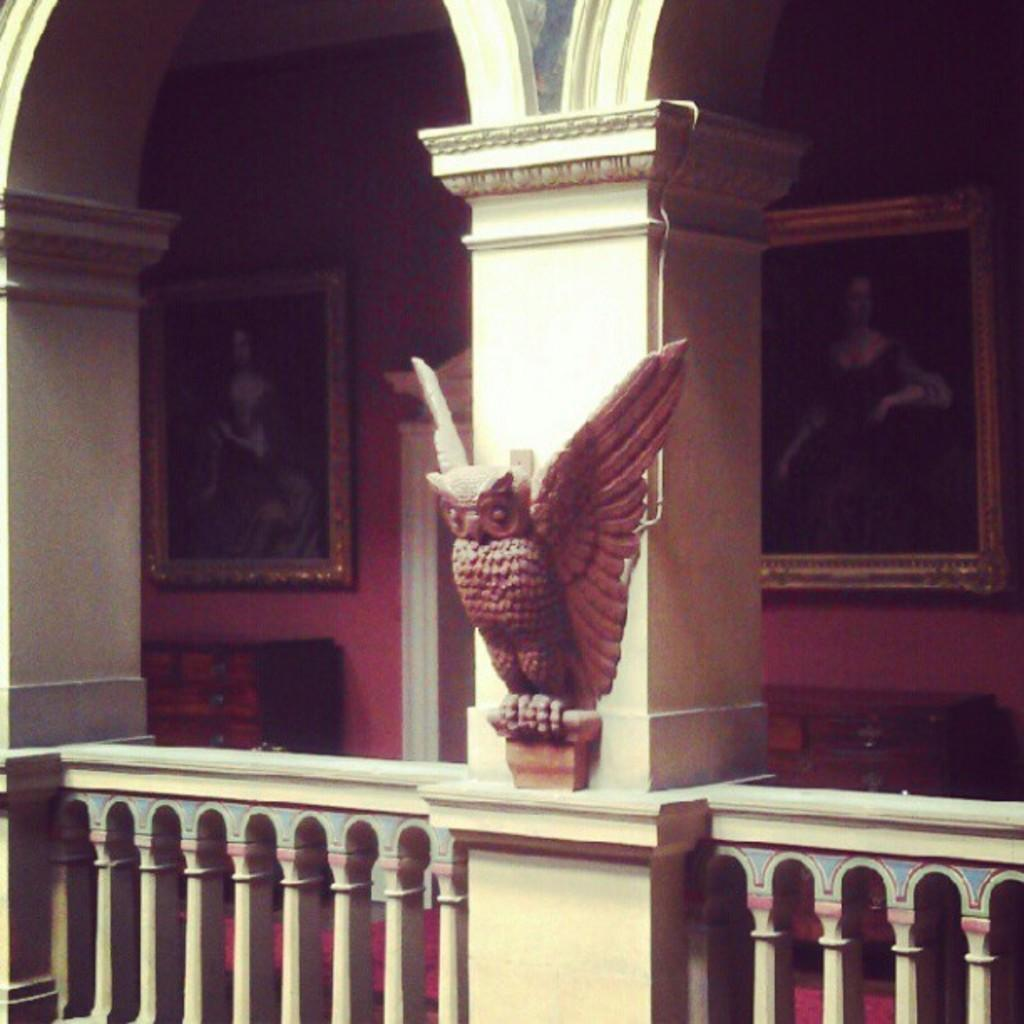What type of statue is in the image? There is a statue of an owl in the image. What architectural elements can be seen in the image? Balusters and pillars are visible in the image. Are there any other objects or features in the image? Yes, there are other objects in the image. What can be seen on the wall in the background of the image? There are frames attached to the wall in the background of the image. What direction is the pickle facing in the image? There is no pickle present in the image, so it cannot be determined which direction it might be facing. 